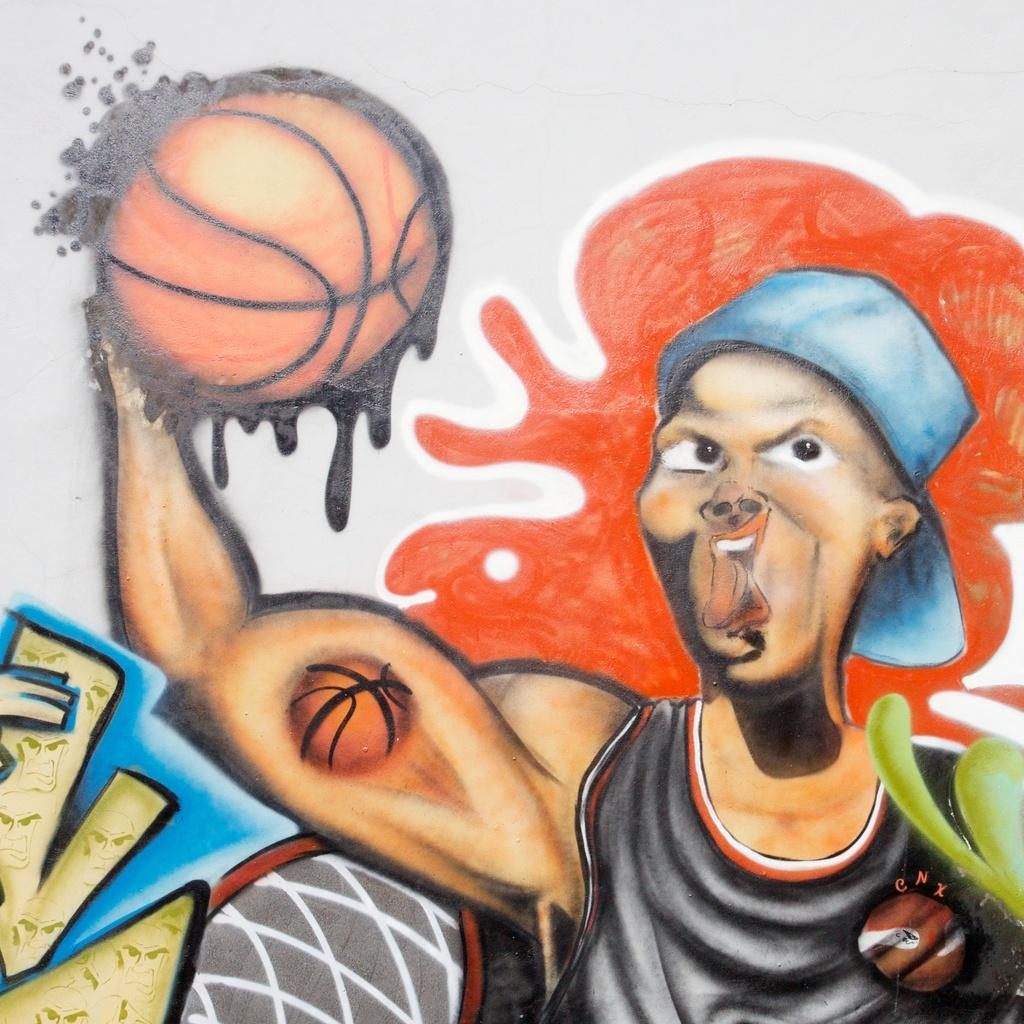What is depicted on the wall in the image? There is a painting on a wall in the image. Can you describe the painting in any way? Unfortunately, the provided facts do not give any details about the painting's content or style. Is there anything else on the wall besides the painting? The provided facts do not mention any other objects or features on the wall. How many trays are stacked on top of the painting in the image? There are no trays present in the image; the only object mentioned is the painting on the wall. 